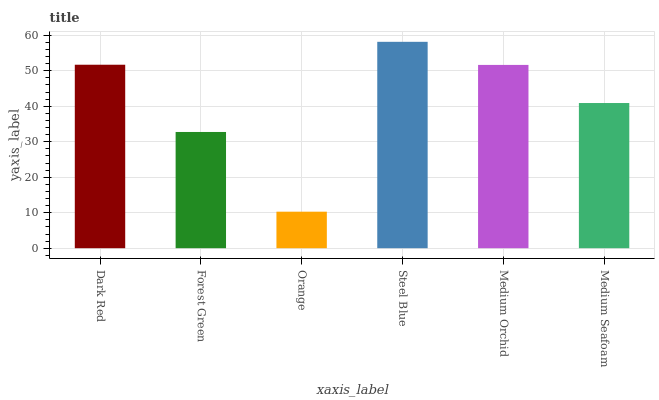Is Forest Green the minimum?
Answer yes or no. No. Is Forest Green the maximum?
Answer yes or no. No. Is Dark Red greater than Forest Green?
Answer yes or no. Yes. Is Forest Green less than Dark Red?
Answer yes or no. Yes. Is Forest Green greater than Dark Red?
Answer yes or no. No. Is Dark Red less than Forest Green?
Answer yes or no. No. Is Medium Orchid the high median?
Answer yes or no. Yes. Is Medium Seafoam the low median?
Answer yes or no. Yes. Is Medium Seafoam the high median?
Answer yes or no. No. Is Orange the low median?
Answer yes or no. No. 